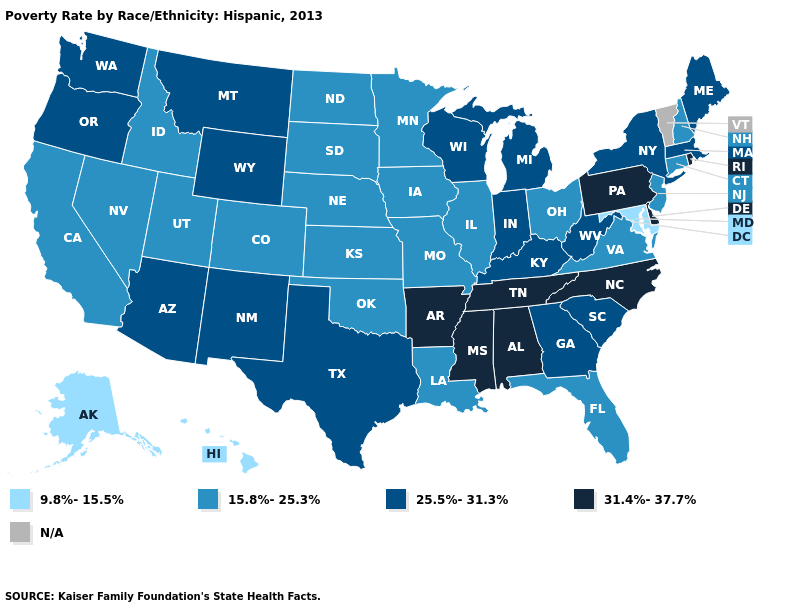What is the highest value in the South ?
Keep it brief. 31.4%-37.7%. What is the highest value in states that border Kentucky?
Be succinct. 31.4%-37.7%. What is the highest value in states that border Montana?
Give a very brief answer. 25.5%-31.3%. What is the value of Wyoming?
Give a very brief answer. 25.5%-31.3%. What is the highest value in the USA?
Write a very short answer. 31.4%-37.7%. What is the value of Arizona?
Short answer required. 25.5%-31.3%. What is the value of Florida?
Be succinct. 15.8%-25.3%. Name the states that have a value in the range 9.8%-15.5%?
Answer briefly. Alaska, Hawaii, Maryland. Does the first symbol in the legend represent the smallest category?
Give a very brief answer. Yes. Does Utah have the highest value in the West?
Quick response, please. No. What is the highest value in the USA?
Answer briefly. 31.4%-37.7%. What is the value of Mississippi?
Give a very brief answer. 31.4%-37.7%. Does Maryland have the lowest value in the South?
Quick response, please. Yes. What is the value of Virginia?
Write a very short answer. 15.8%-25.3%. 